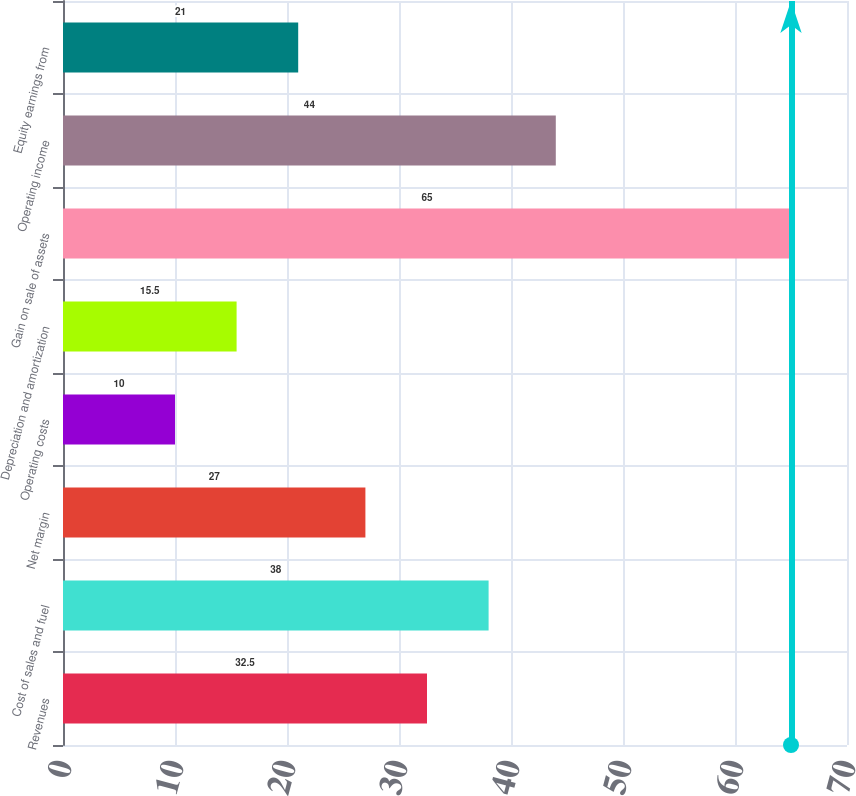Convert chart. <chart><loc_0><loc_0><loc_500><loc_500><bar_chart><fcel>Revenues<fcel>Cost of sales and fuel<fcel>Net margin<fcel>Operating costs<fcel>Depreciation and amortization<fcel>Gain on sale of assets<fcel>Operating income<fcel>Equity earnings from<nl><fcel>32.5<fcel>38<fcel>27<fcel>10<fcel>15.5<fcel>65<fcel>44<fcel>21<nl></chart> 